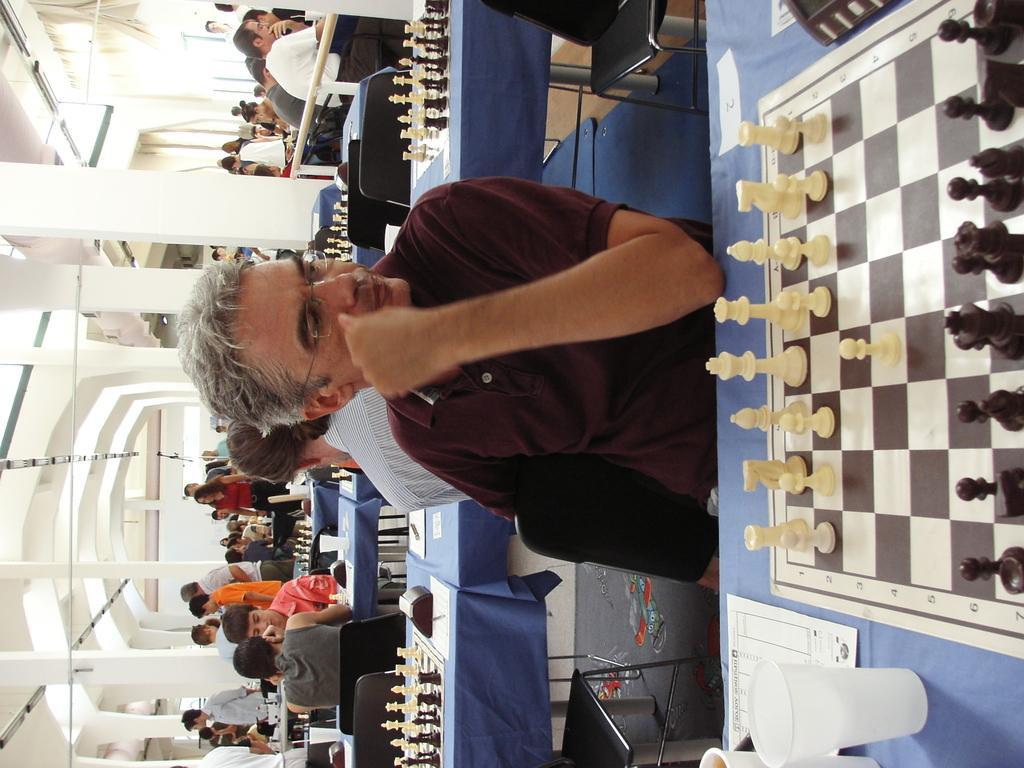Please provide a concise description of this image. There are few people sitting on the chairs and few are standing. This is a table covered with blue color cloth. These are the chess coins placed on the chess board,a tumbler,paper placed on the table. At background I can see people playing chess,and I can find few chess boards with chess coins on the table. This is the pillar. 